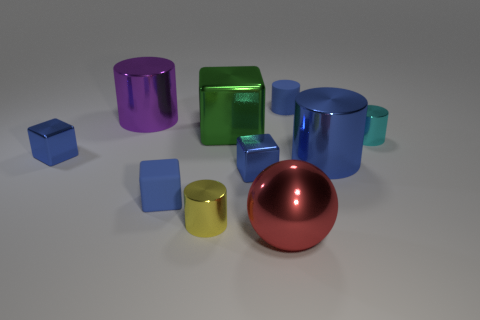How many other small blocks are the same color as the small matte cube?
Keep it short and to the point. 2. Does the tiny matte cube have the same color as the tiny matte object that is to the right of the big red shiny sphere?
Offer a terse response. Yes. What is the shape of the small blue thing that is both to the right of the small yellow metallic cylinder and in front of the matte cylinder?
Provide a succinct answer. Cube. There is a big cylinder right of the big shiny object that is in front of the tiny matte thing in front of the purple thing; what is its material?
Your response must be concise. Metal. Are there more metallic cylinders right of the large cube than small blue matte cylinders on the left side of the large blue thing?
Provide a succinct answer. Yes. How many red objects are the same material as the big cube?
Offer a very short reply. 1. There is a thing to the right of the large blue cylinder; does it have the same shape as the small rubber object that is behind the small cyan metallic cylinder?
Ensure brevity in your answer.  Yes. There is a matte thing behind the tiny cyan metallic cylinder; what is its color?
Give a very brief answer. Blue. Is there a cyan thing that has the same shape as the purple metallic thing?
Give a very brief answer. Yes. What material is the ball?
Your answer should be compact. Metal. 